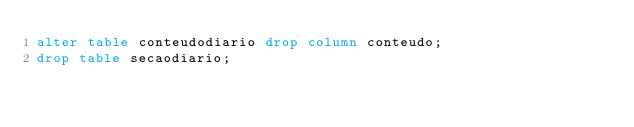<code> <loc_0><loc_0><loc_500><loc_500><_SQL_>alter table conteudodiario drop column conteudo;
drop table secaodiario;</code> 